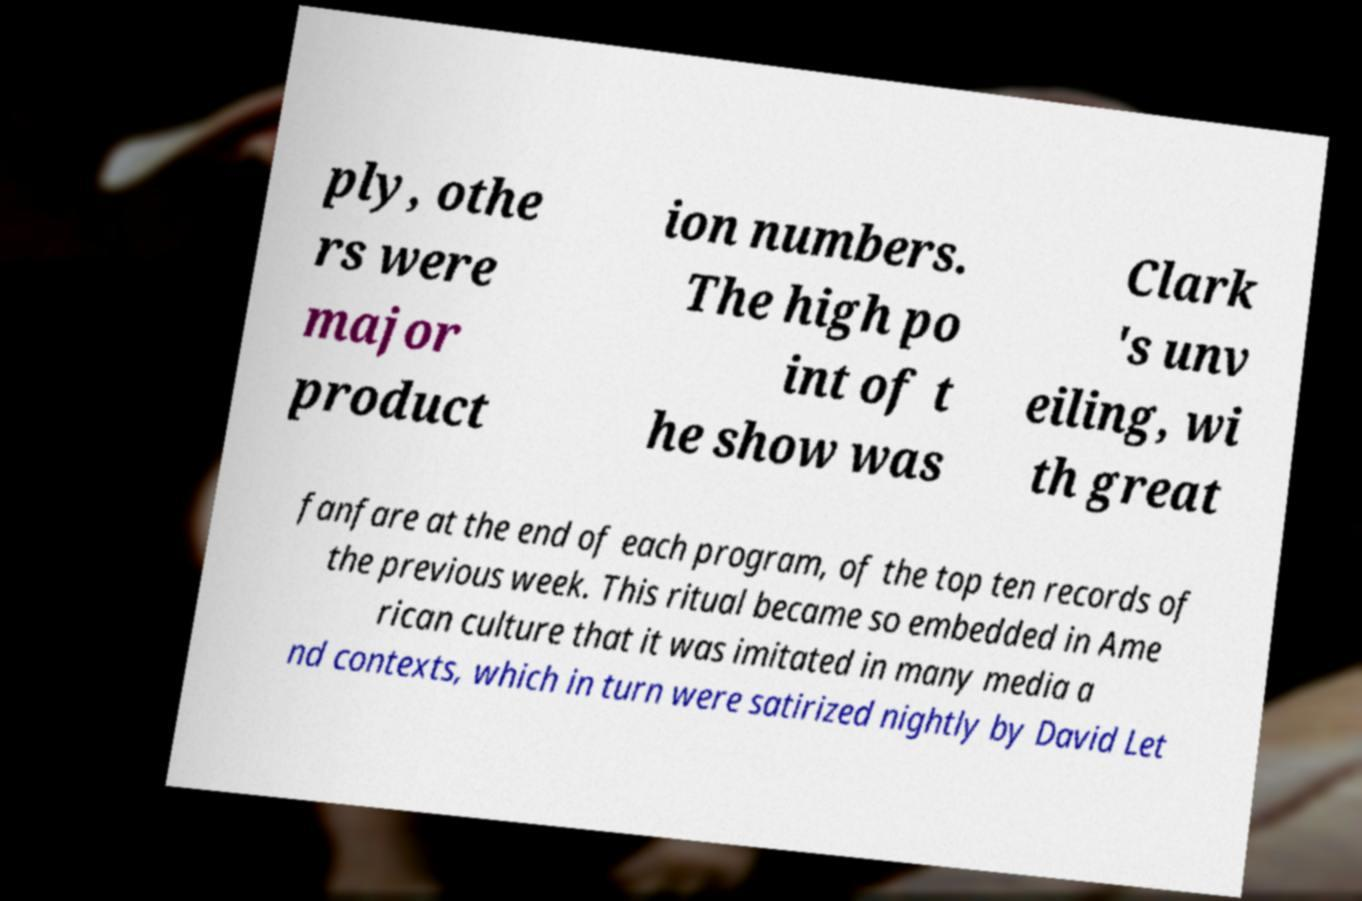Please read and relay the text visible in this image. What does it say? ply, othe rs were major product ion numbers. The high po int of t he show was Clark 's unv eiling, wi th great fanfare at the end of each program, of the top ten records of the previous week. This ritual became so embedded in Ame rican culture that it was imitated in many media a nd contexts, which in turn were satirized nightly by David Let 